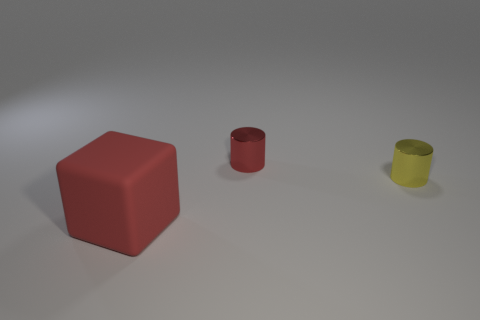What material is the tiny cylinder that is the same color as the block?
Provide a short and direct response. Metal. How many blocks are large objects or large blue matte objects?
Your response must be concise. 1. Do the large matte thing and the small yellow object have the same shape?
Give a very brief answer. No. There is a red object on the right side of the large matte thing; what size is it?
Offer a very short reply. Small. Are there any metallic cylinders that have the same color as the big object?
Provide a short and direct response. Yes. Does the shiny thing on the left side of the yellow thing have the same size as the large block?
Provide a succinct answer. No. What color is the matte block?
Your response must be concise. Red. There is a metal cylinder that is in front of the red object behind the big cube; what color is it?
Offer a very short reply. Yellow. Are there any big red things that have the same material as the red cube?
Offer a very short reply. No. What is the material of the red thing right of the red object that is left of the small red shiny thing?
Keep it short and to the point. Metal. 